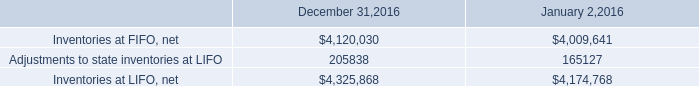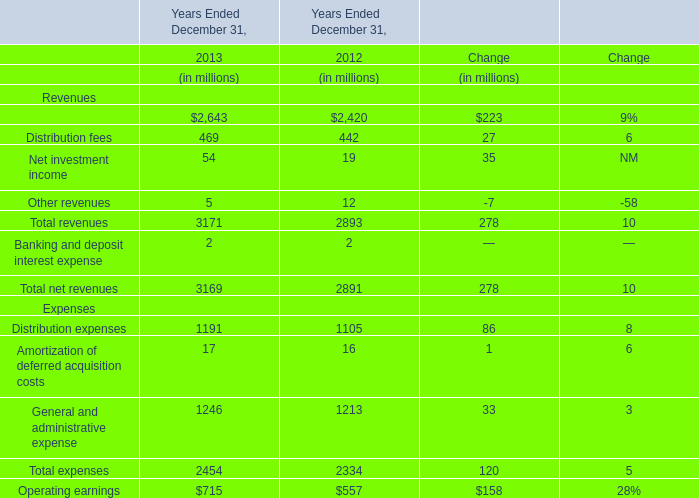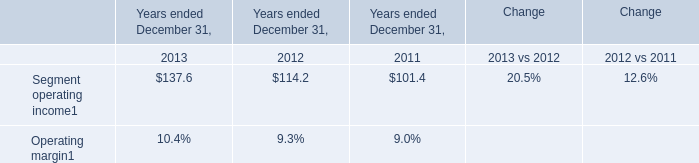how much did the inventory overhead costs purchasing and warehousing costs increase in the year of 2016? 
Computations: ((395240 - 359829) / 359829)
Answer: 0.09841. 